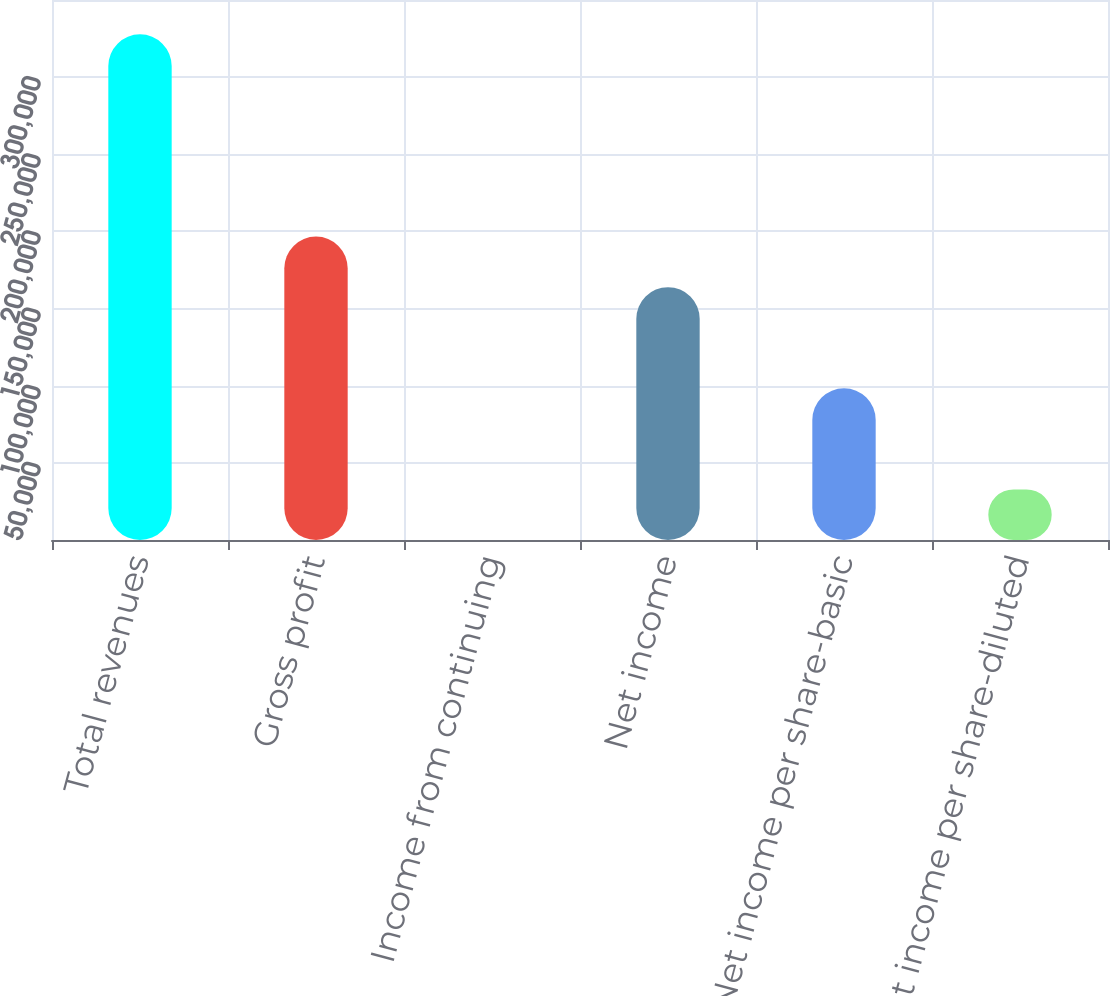Convert chart. <chart><loc_0><loc_0><loc_500><loc_500><bar_chart><fcel>Total revenues<fcel>Gross profit<fcel>Income from continuing<fcel>Net income<fcel>Net income per share-basic<fcel>Net income per share-diluted<nl><fcel>327720<fcel>196632<fcel>0.23<fcel>163860<fcel>98316.2<fcel>32772.2<nl></chart> 